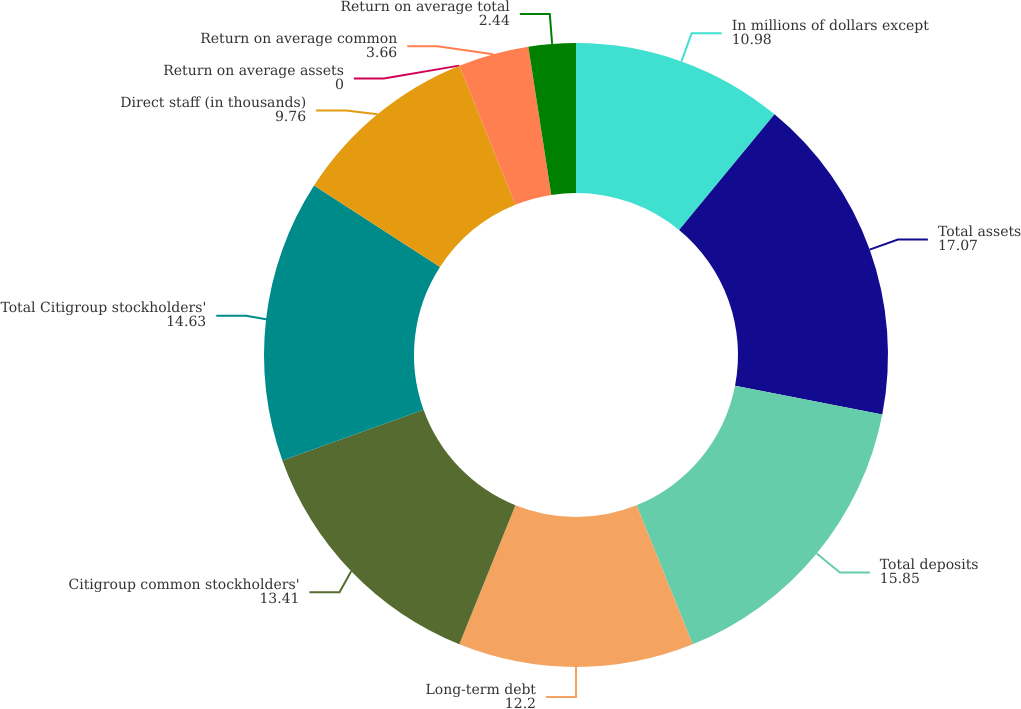Convert chart. <chart><loc_0><loc_0><loc_500><loc_500><pie_chart><fcel>In millions of dollars except<fcel>Total assets<fcel>Total deposits<fcel>Long-term debt<fcel>Citigroup common stockholders'<fcel>Total Citigroup stockholders'<fcel>Direct staff (in thousands)<fcel>Return on average assets<fcel>Return on average common<fcel>Return on average total<nl><fcel>10.98%<fcel>17.07%<fcel>15.85%<fcel>12.2%<fcel>13.41%<fcel>14.63%<fcel>9.76%<fcel>0.0%<fcel>3.66%<fcel>2.44%<nl></chart> 